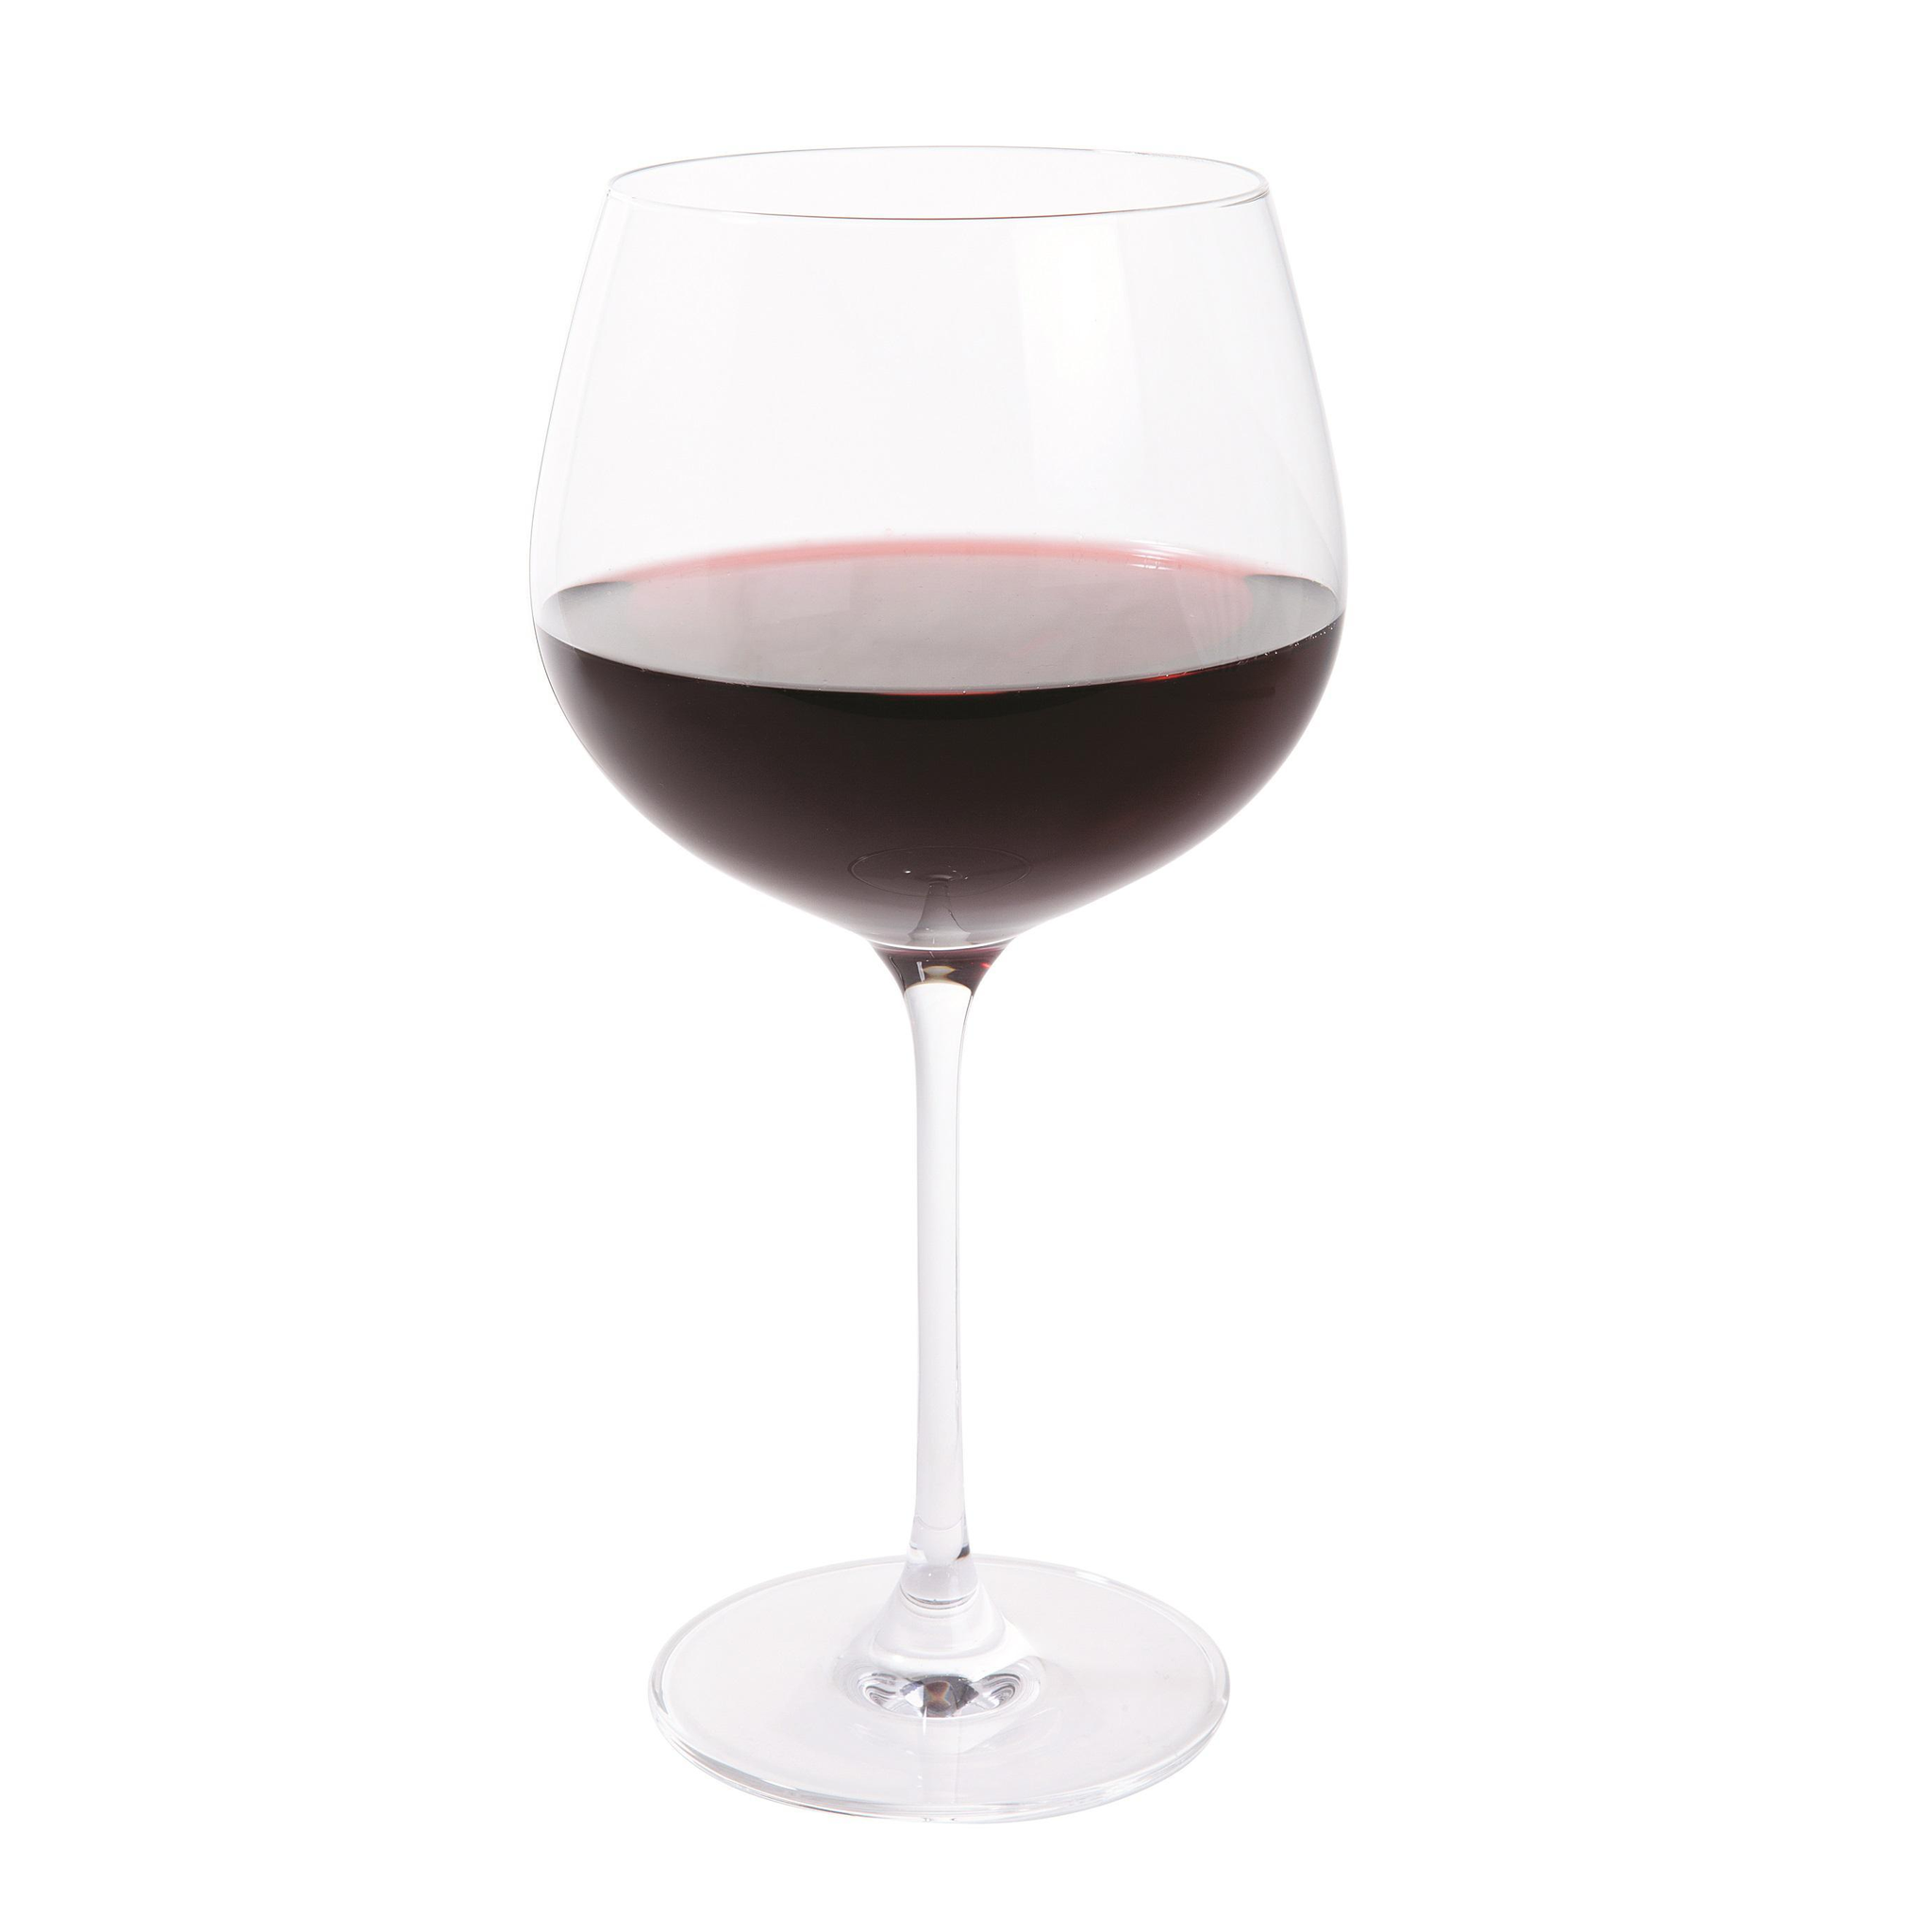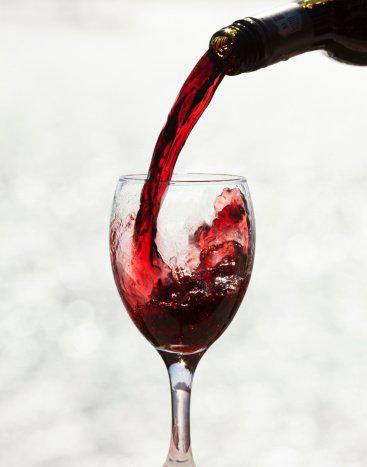The first image is the image on the left, the second image is the image on the right. Examine the images to the left and right. Is the description "At least one glass of wine is active and swirling around the wine glass." accurate? Answer yes or no. Yes. The first image is the image on the left, the second image is the image on the right. Analyze the images presented: Is the assertion "An image shows red wine splashing up the side of at least one stemmed glass." valid? Answer yes or no. Yes. 